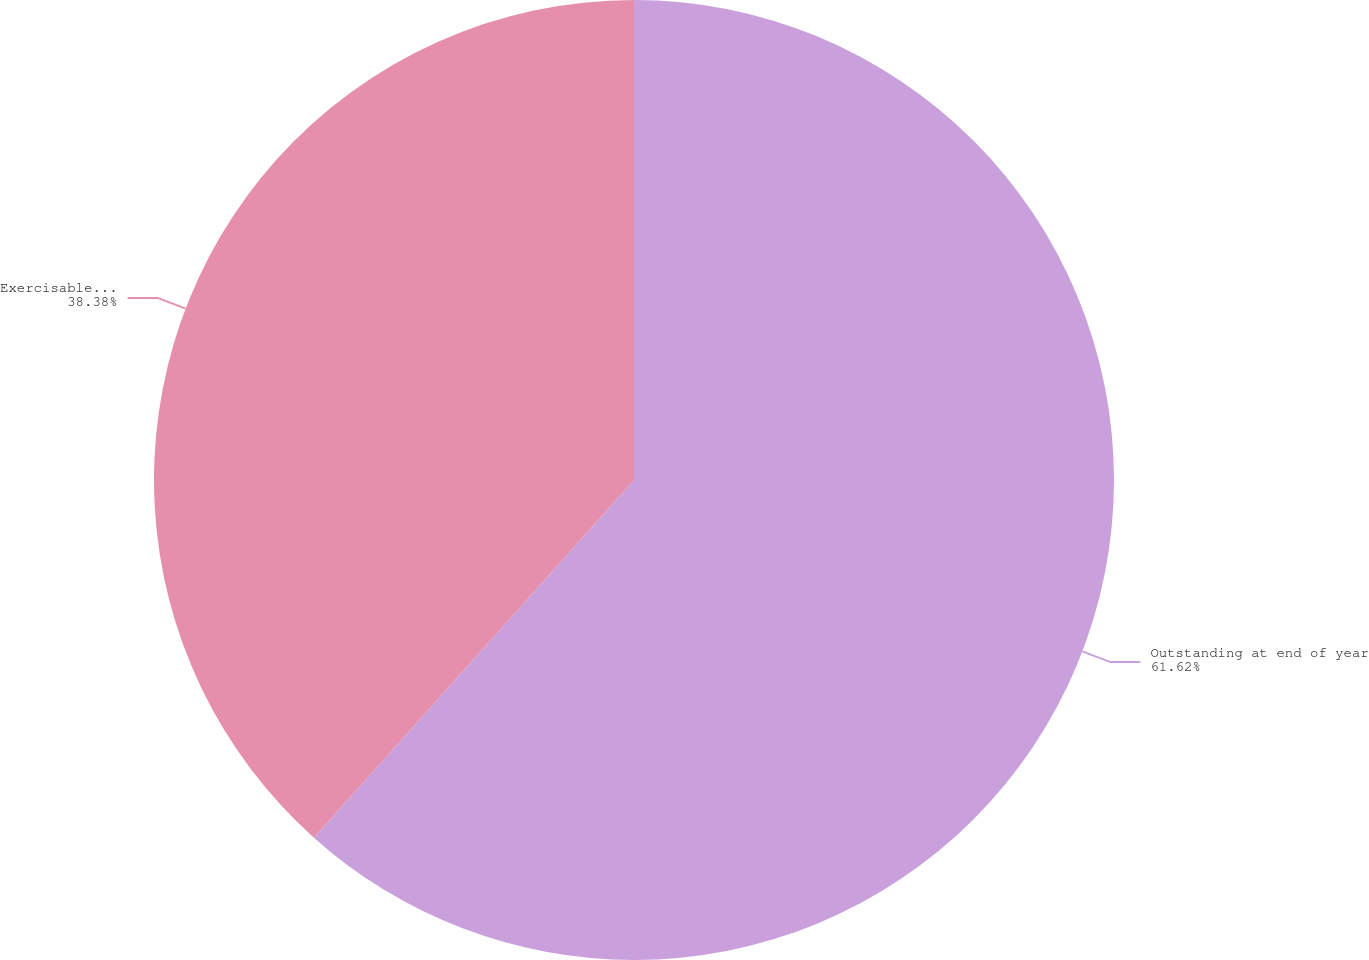Convert chart to OTSL. <chart><loc_0><loc_0><loc_500><loc_500><pie_chart><fcel>Outstanding at end of year<fcel>Exercisable at end of year<nl><fcel>61.62%<fcel>38.38%<nl></chart> 